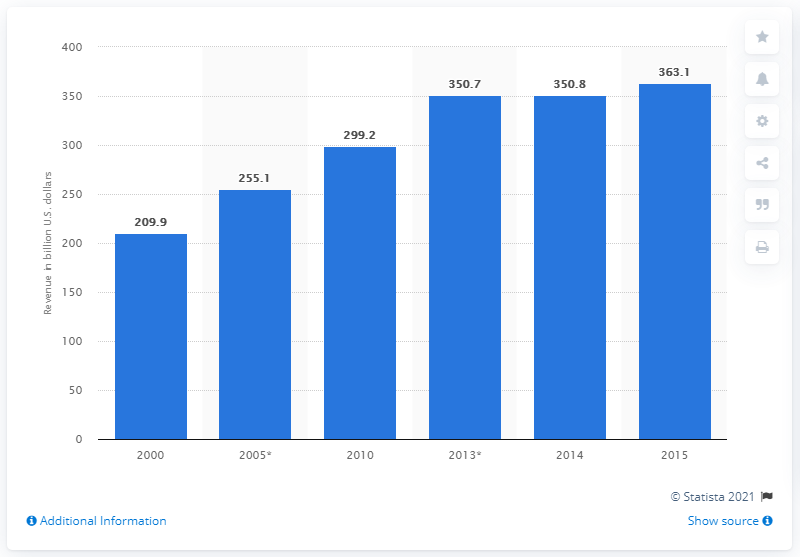Mention a couple of crucial points in this snapshot. According to a report released in 2015, the environmental industry generated a total of $363.1 billion in revenue. 